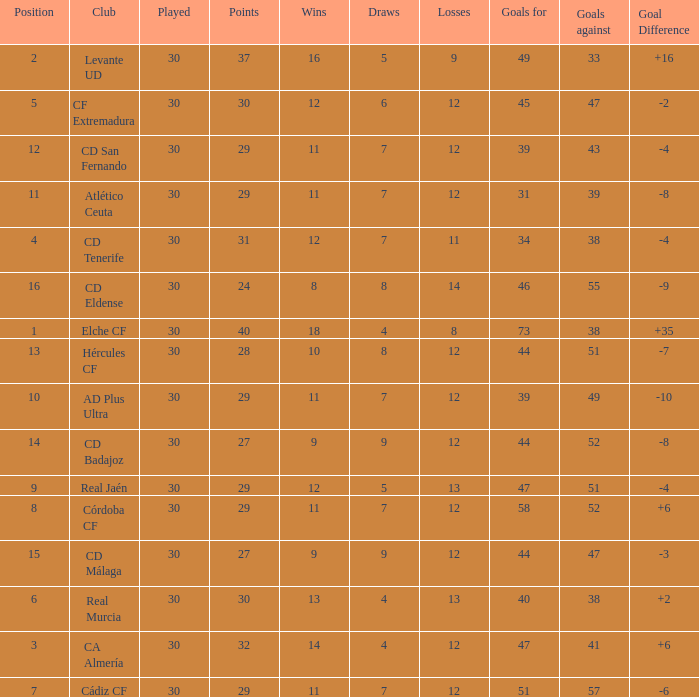What is the average number of goals against with more than 12 wins, 12 losses, and a position greater than 3? None. 